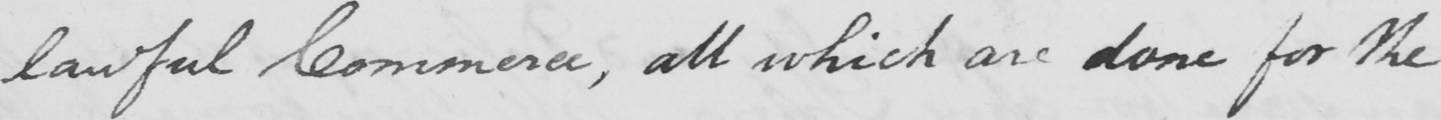What text is written in this handwritten line? lawful Commerce , all of which are done for the 